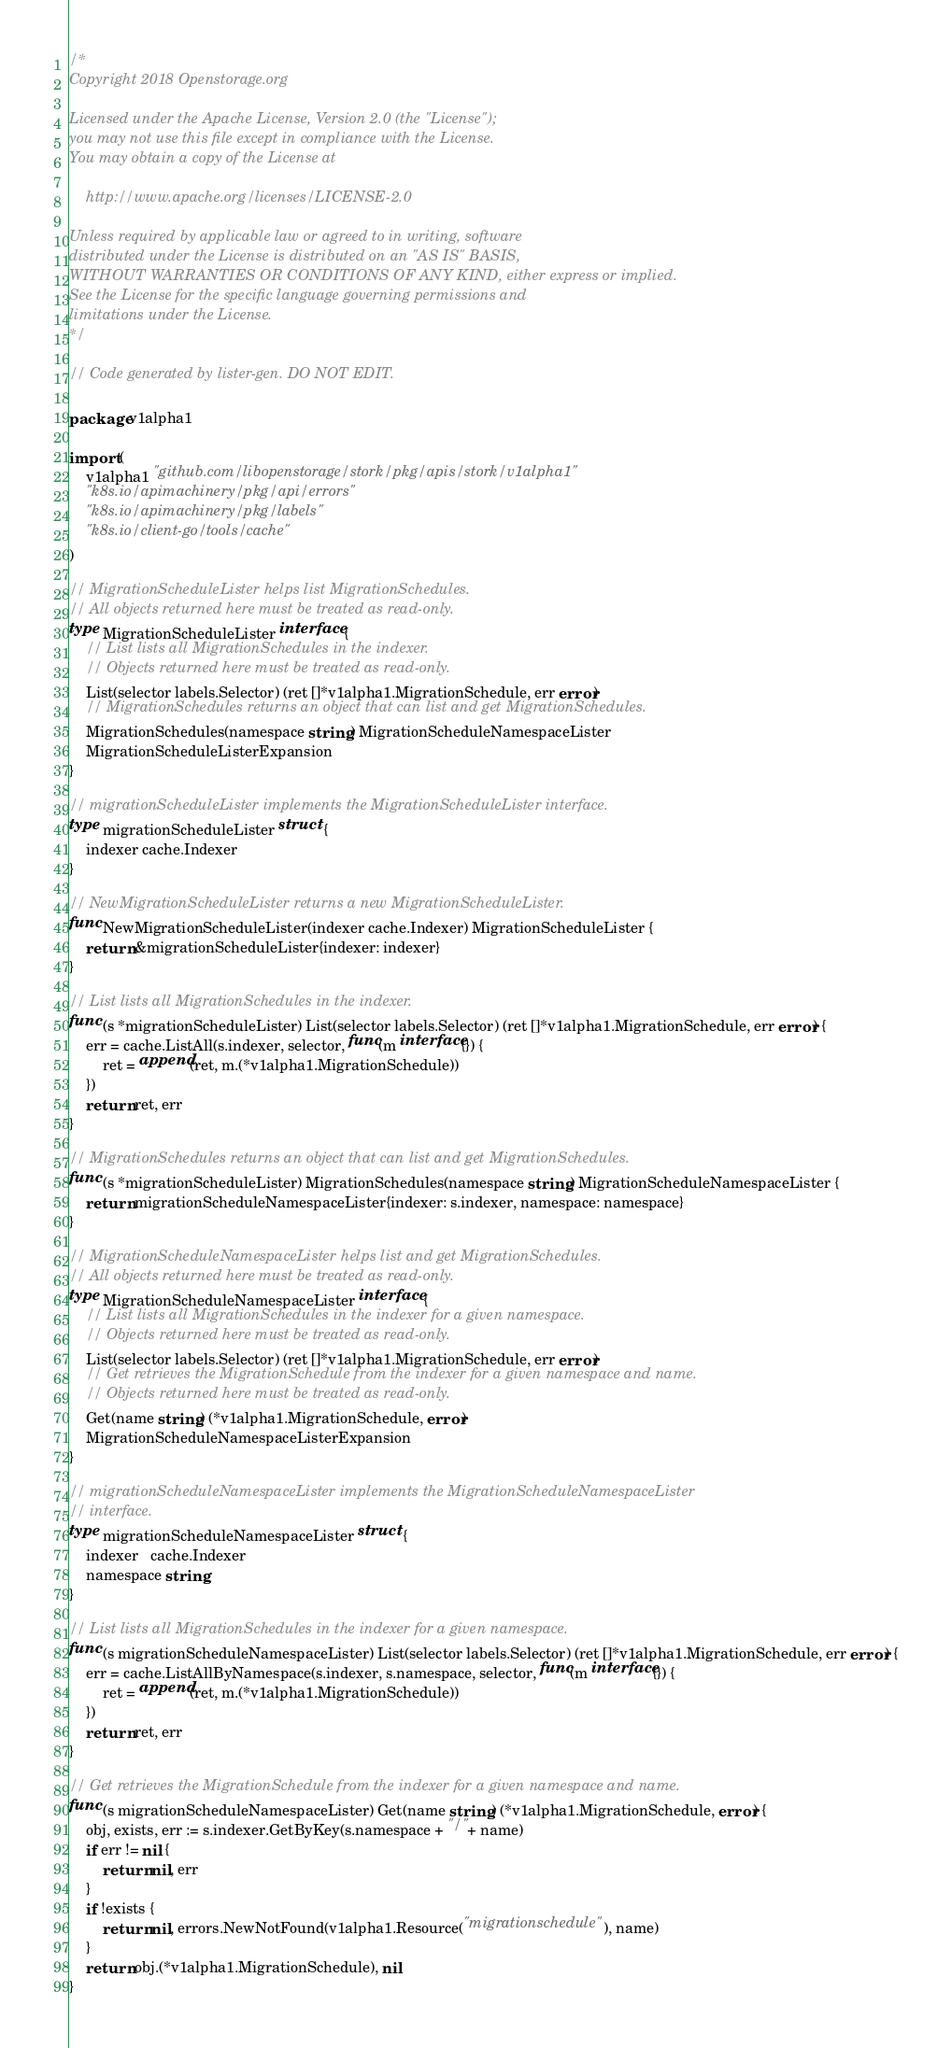Convert code to text. <code><loc_0><loc_0><loc_500><loc_500><_Go_>/*
Copyright 2018 Openstorage.org

Licensed under the Apache License, Version 2.0 (the "License");
you may not use this file except in compliance with the License.
You may obtain a copy of the License at

    http://www.apache.org/licenses/LICENSE-2.0

Unless required by applicable law or agreed to in writing, software
distributed under the License is distributed on an "AS IS" BASIS,
WITHOUT WARRANTIES OR CONDITIONS OF ANY KIND, either express or implied.
See the License for the specific language governing permissions and
limitations under the License.
*/

// Code generated by lister-gen. DO NOT EDIT.

package v1alpha1

import (
	v1alpha1 "github.com/libopenstorage/stork/pkg/apis/stork/v1alpha1"
	"k8s.io/apimachinery/pkg/api/errors"
	"k8s.io/apimachinery/pkg/labels"
	"k8s.io/client-go/tools/cache"
)

// MigrationScheduleLister helps list MigrationSchedules.
// All objects returned here must be treated as read-only.
type MigrationScheduleLister interface {
	// List lists all MigrationSchedules in the indexer.
	// Objects returned here must be treated as read-only.
	List(selector labels.Selector) (ret []*v1alpha1.MigrationSchedule, err error)
	// MigrationSchedules returns an object that can list and get MigrationSchedules.
	MigrationSchedules(namespace string) MigrationScheduleNamespaceLister
	MigrationScheduleListerExpansion
}

// migrationScheduleLister implements the MigrationScheduleLister interface.
type migrationScheduleLister struct {
	indexer cache.Indexer
}

// NewMigrationScheduleLister returns a new MigrationScheduleLister.
func NewMigrationScheduleLister(indexer cache.Indexer) MigrationScheduleLister {
	return &migrationScheduleLister{indexer: indexer}
}

// List lists all MigrationSchedules in the indexer.
func (s *migrationScheduleLister) List(selector labels.Selector) (ret []*v1alpha1.MigrationSchedule, err error) {
	err = cache.ListAll(s.indexer, selector, func(m interface{}) {
		ret = append(ret, m.(*v1alpha1.MigrationSchedule))
	})
	return ret, err
}

// MigrationSchedules returns an object that can list and get MigrationSchedules.
func (s *migrationScheduleLister) MigrationSchedules(namespace string) MigrationScheduleNamespaceLister {
	return migrationScheduleNamespaceLister{indexer: s.indexer, namespace: namespace}
}

// MigrationScheduleNamespaceLister helps list and get MigrationSchedules.
// All objects returned here must be treated as read-only.
type MigrationScheduleNamespaceLister interface {
	// List lists all MigrationSchedules in the indexer for a given namespace.
	// Objects returned here must be treated as read-only.
	List(selector labels.Selector) (ret []*v1alpha1.MigrationSchedule, err error)
	// Get retrieves the MigrationSchedule from the indexer for a given namespace and name.
	// Objects returned here must be treated as read-only.
	Get(name string) (*v1alpha1.MigrationSchedule, error)
	MigrationScheduleNamespaceListerExpansion
}

// migrationScheduleNamespaceLister implements the MigrationScheduleNamespaceLister
// interface.
type migrationScheduleNamespaceLister struct {
	indexer   cache.Indexer
	namespace string
}

// List lists all MigrationSchedules in the indexer for a given namespace.
func (s migrationScheduleNamespaceLister) List(selector labels.Selector) (ret []*v1alpha1.MigrationSchedule, err error) {
	err = cache.ListAllByNamespace(s.indexer, s.namespace, selector, func(m interface{}) {
		ret = append(ret, m.(*v1alpha1.MigrationSchedule))
	})
	return ret, err
}

// Get retrieves the MigrationSchedule from the indexer for a given namespace and name.
func (s migrationScheduleNamespaceLister) Get(name string) (*v1alpha1.MigrationSchedule, error) {
	obj, exists, err := s.indexer.GetByKey(s.namespace + "/" + name)
	if err != nil {
		return nil, err
	}
	if !exists {
		return nil, errors.NewNotFound(v1alpha1.Resource("migrationschedule"), name)
	}
	return obj.(*v1alpha1.MigrationSchedule), nil
}
</code> 